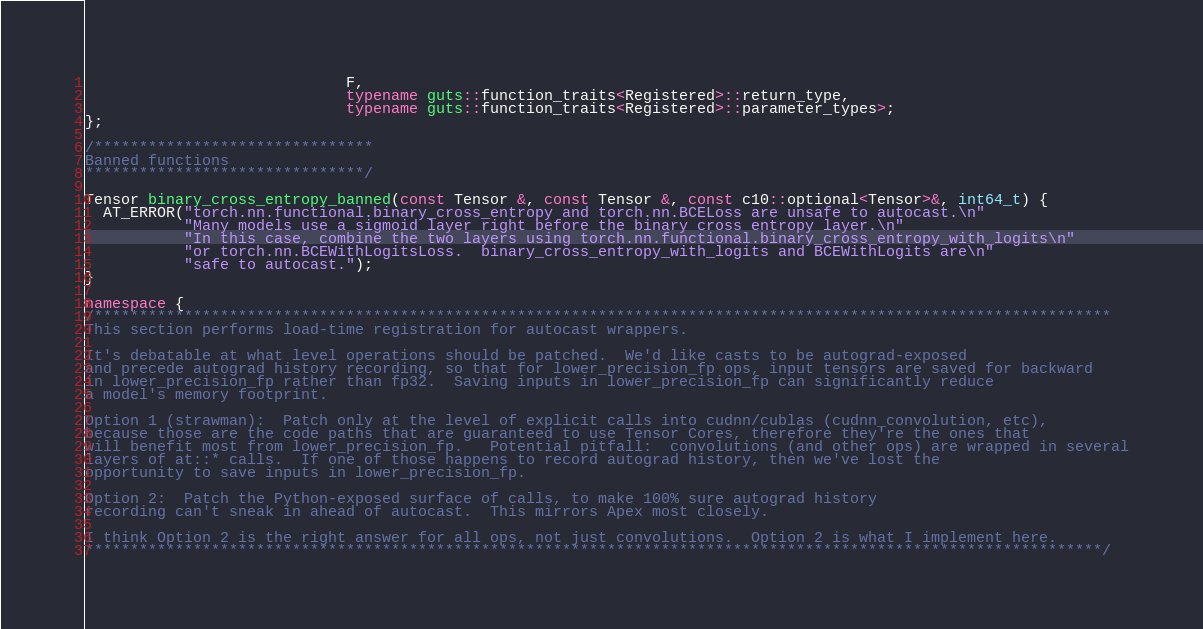Convert code to text. <code><loc_0><loc_0><loc_500><loc_500><_C++_>                             F,
                             typename guts::function_traits<Registered>::return_type,
                             typename guts::function_traits<Registered>::parameter_types>;
};

/*******************************
Banned functions
*******************************/

Tensor binary_cross_entropy_banned(const Tensor &, const Tensor &, const c10::optional<Tensor>&, int64_t) {
  AT_ERROR("torch.nn.functional.binary_cross_entropy and torch.nn.BCELoss are unsafe to autocast.\n"
           "Many models use a sigmoid layer right before the binary cross entropy layer.\n"
           "In this case, combine the two layers using torch.nn.functional.binary_cross_entropy_with_logits\n"
           "or torch.nn.BCEWithLogitsLoss.  binary_cross_entropy_with_logits and BCEWithLogits are\n"
           "safe to autocast.");
}

namespace {
/*****************************************************************************************************************
This section performs load-time registration for autocast wrappers.

It's debatable at what level operations should be patched.  We'd like casts to be autograd-exposed
and precede autograd history recording, so that for lower_precision_fp ops, input tensors are saved for backward
in lower_precision_fp rather than fp32.  Saving inputs in lower_precision_fp can significantly reduce
a model's memory footprint.

Option 1 (strawman):  Patch only at the level of explicit calls into cudnn/cublas (cudnn_convolution, etc),
because those are the code paths that are guaranteed to use Tensor Cores, therefore they're the ones that
will benefit most from lower_precision_fp.   Potential pitfall:  convolutions (and other ops) are wrapped in several
layers of at::* calls.  If one of those happens to record autograd history, then we've lost the
opportunity to save inputs in lower_precision_fp.

Option 2:  Patch the Python-exposed surface of calls, to make 100% sure autograd history
recording can't sneak in ahead of autocast.  This mirrors Apex most closely.

I think Option 2 is the right answer for all ops, not just convolutions.  Option 2 is what I implement here.
*****************************************************************************************************************/
</code> 